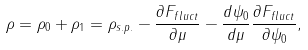<formula> <loc_0><loc_0><loc_500><loc_500>\rho = \rho _ { 0 } + \rho _ { 1 } = \rho _ { s . p . } - \frac { \partial F _ { f l u c t } } { \partial \mu } - \frac { d \psi _ { 0 } } { d \mu } \frac { \partial F _ { f l u c t } } { \partial \psi _ { 0 } } ,</formula> 